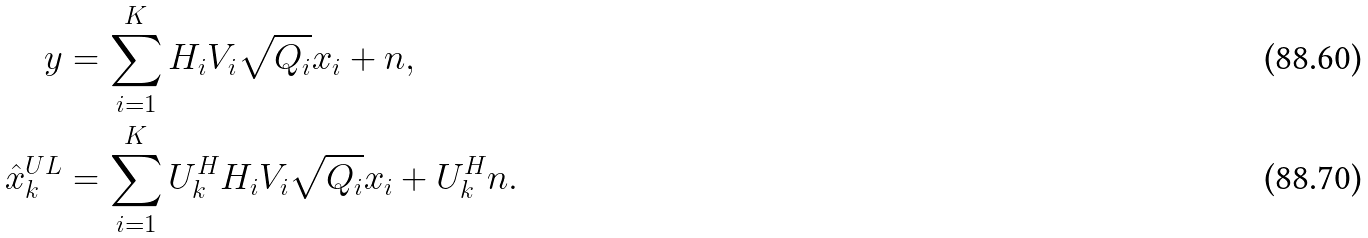<formula> <loc_0><loc_0><loc_500><loc_500>y & = \sum _ { i = 1 } ^ { K } H _ { i } V _ { i } \sqrt { Q _ { i } } x _ { i } + n , \\ \hat { x } _ { k } ^ { U L } & = \sum _ { i = 1 } ^ { K } U _ { k } ^ { H } H _ { i } V _ { i } \sqrt { Q _ { i } } x _ { i } + U _ { k } ^ { H } n .</formula> 